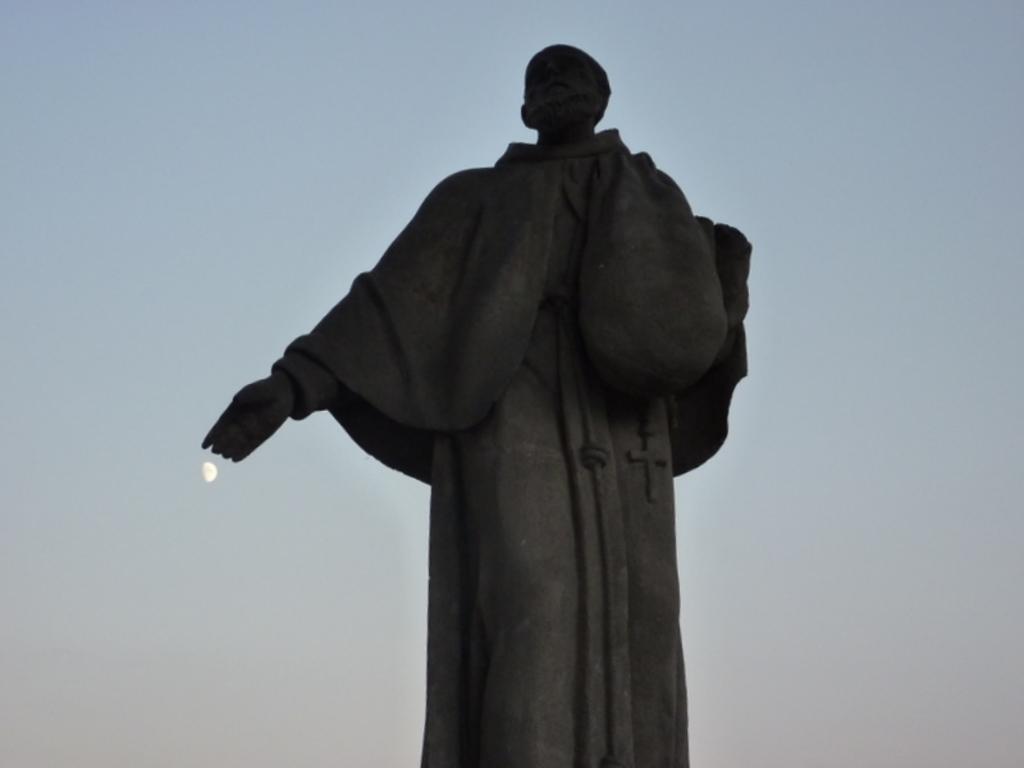Can you describe this image briefly? In the picture I can see the statue. I can see the moon and clouds in the sky. 